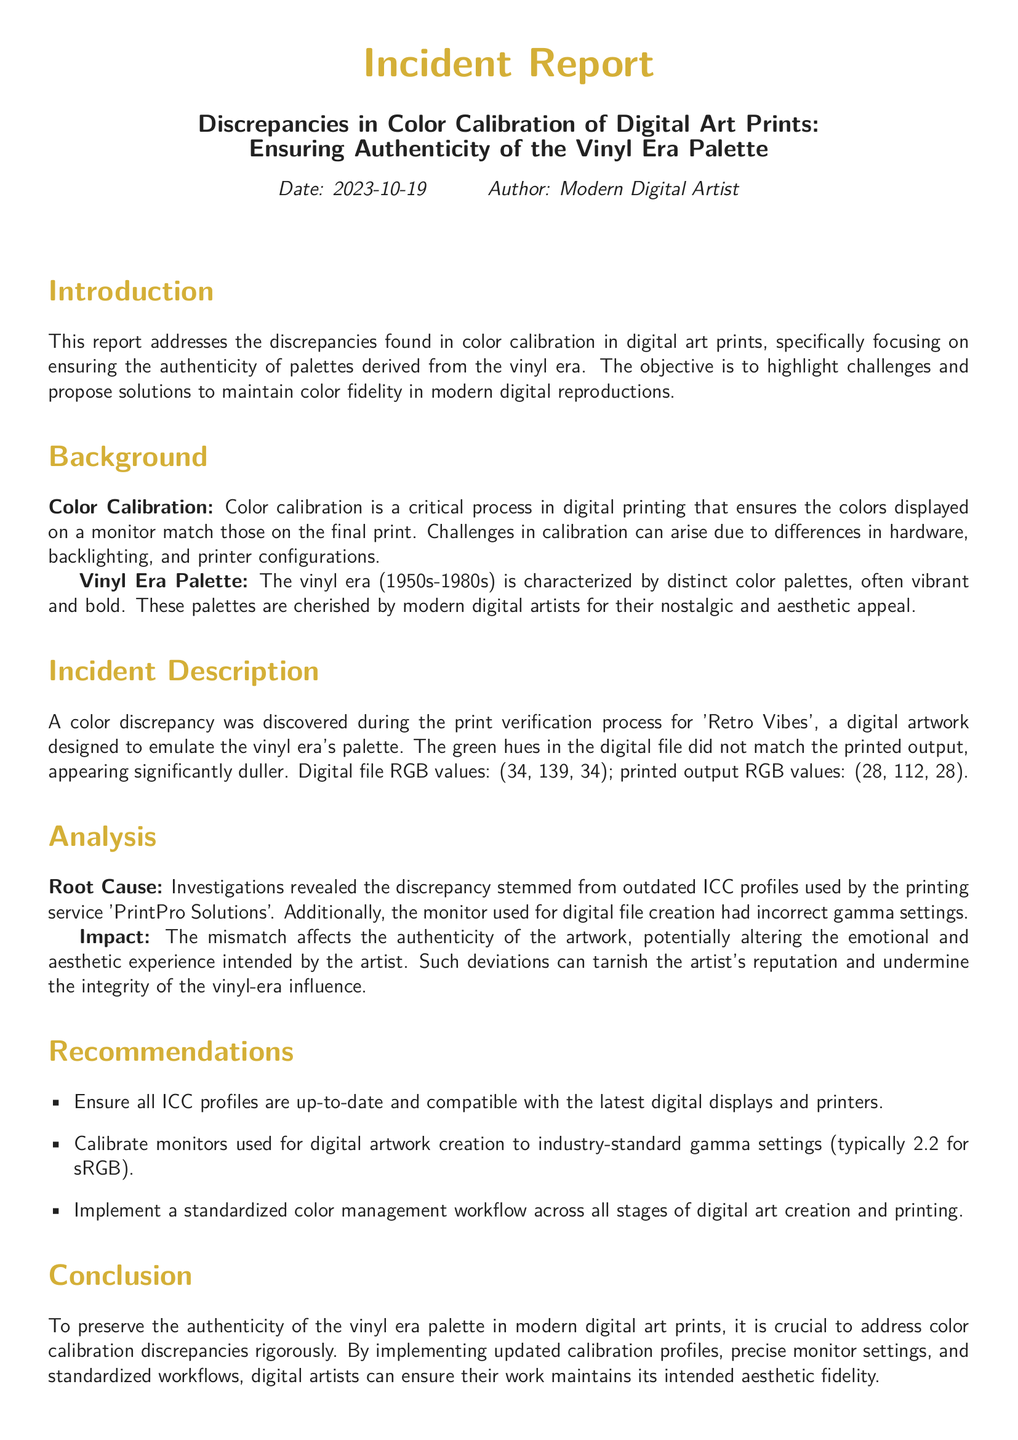What is the date of the incident report? The date of the report is stated at the beginning of the document.
Answer: 2023-10-19 Who authored the incident report? The author of the report is indicated in the header section.
Answer: Modern Digital Artist What colors are defined for vinyl black and vinyl gold? The defined RGB colors for vinyl black and gold are specified in the document.
Answer: RGB: (33, 33, 33) and RGB: (212, 175, 55) What was the RGB value of the digital file's green hues? The RGB value is provided in the incident description.
Answer: (34, 139, 34) What is the recommended gamma setting for monitor calibration? The recommended gamma setting is given in the recommendations section.
Answer: 2.2 What printing service was involved in the color discrepancy? The name of the printing service is mentioned in the analysis section.
Answer: PrintPro Solutions How did the color discrepancy impact the authenticity of the artwork? The document discusses the impact on authenticity in the analysis section.
Answer: Altering the emotional and aesthetic experience What is the main objective of this report? The objective is outlined in the introduction section of the report.
Answer: Highlight challenges and propose solutions What was the printed output's RGB value for the green hues? The value is listed in the incident description for comparison.
Answer: (28, 112, 28) 